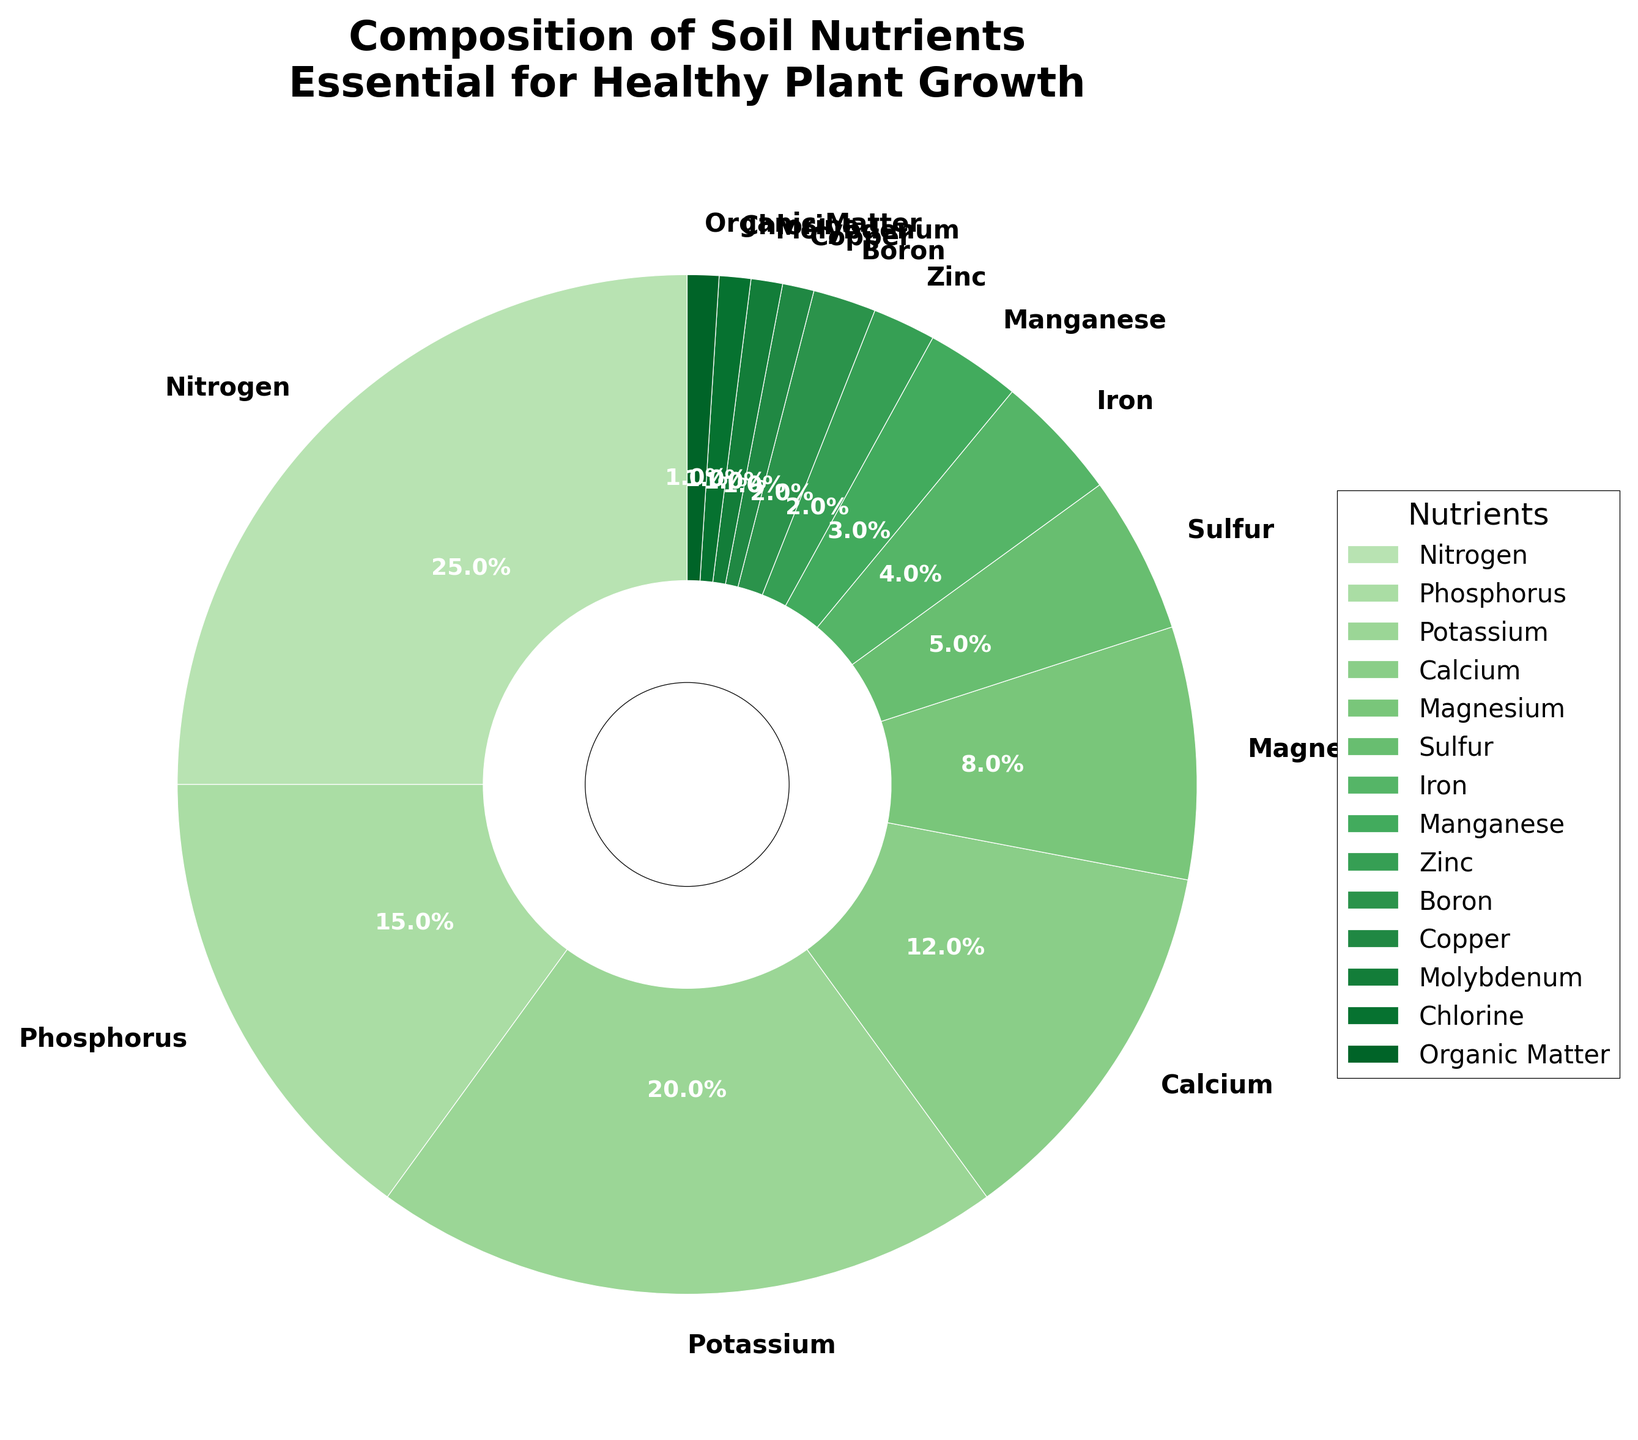What are the three most abundant nutrients in the soil composition? By examining the pie chart, we identify the segments with the largest areas. The three largest segments, based on their percentages, are Nitrogen, Potassium, and Phosphorus.
Answer: Nitrogen, Potassium, Phosphorus What is the total percentage of micronutrients (elements with a percentage less than or equal to 5%) in the soil? Identify segments with percentages of 5% or less: Sulfur (5%), Iron (4%), Manganese (3%), Zinc (2%), Boron (2%), Copper (1%), Molybdenum (1%), Chlorine (1%), and Organic Matter (1%). Sum these values: 5 + 4 + 3 + 2 + 2 + 1 + 1 + 1 + 1 = 20%
Answer: 20% How does the percentage of Potassium compare to that of Calcium? Identify the segments for Potassium and Calcium. Potassium is 20%, and Calcium is 12%. Subtract Calcium’s percentage from Potassium’s percentage: 20% - 12% = 8%. Thus, Potassium is 8% greater than Calcium.
Answer: Potassium is 8% greater Which nutrient has a percentage equal to the combined percentage of Zinc and Boron? Determine the sum of Zinc and Boron: 2% + 2% = 4%. Then, find a nutrient with the same percentage. Iron stands at 4%, equating it to the combined percentage of Zinc and Boron.
Answer: Iron Does Magnesium constitute a higher percentage than Sulfur and Zinc combined? Identify individual percentages: Magnesium = 8%, Sulfur = 5%, and Zinc = 2%. Sum Sulfur and Zinc: 5% + 2% = 7%. Compare with Magnesium. 8% (Magnesium) is greater than 7% (Sulfur + Zinc).
Answer: Yes What is the ratio of Nitrogen to the combined percentage of Manganese, Copper, Zinc, and Chlorine? Identify individual percentages: Nitrogen = 25%, Manganese = 3%, Copper = 1%, Zinc = 2%, and Chlorine = 1%. Sum the combined percentages: 3% + 1% + 2% + 1% = 7%. The ratio becomes 25:7.
Answer: 25:7 Identify the nutrient with the smallest percentage in the soil composition. Locate the segment with the smallest proportional area. Copper, Molybdenum, Chlorine, and Organic Matter each share the smallest percentage of 1%.
Answer: Copper, Molybdenum, Chlorine, Organic Matter What is the difference between the percentage of Nitrogen and the average percentage of Phosphorus and Potassium? Determine individual percentages: Nitrogen = 25%, Phosphorus = 15%, Potassium = 20%. Calculate the average of Phosphorus and Potassium: (15% + 20%) / 2 = 17.5%. Find the difference: 25% - 17.5% = 7.5%.
Answer: 7.5% 